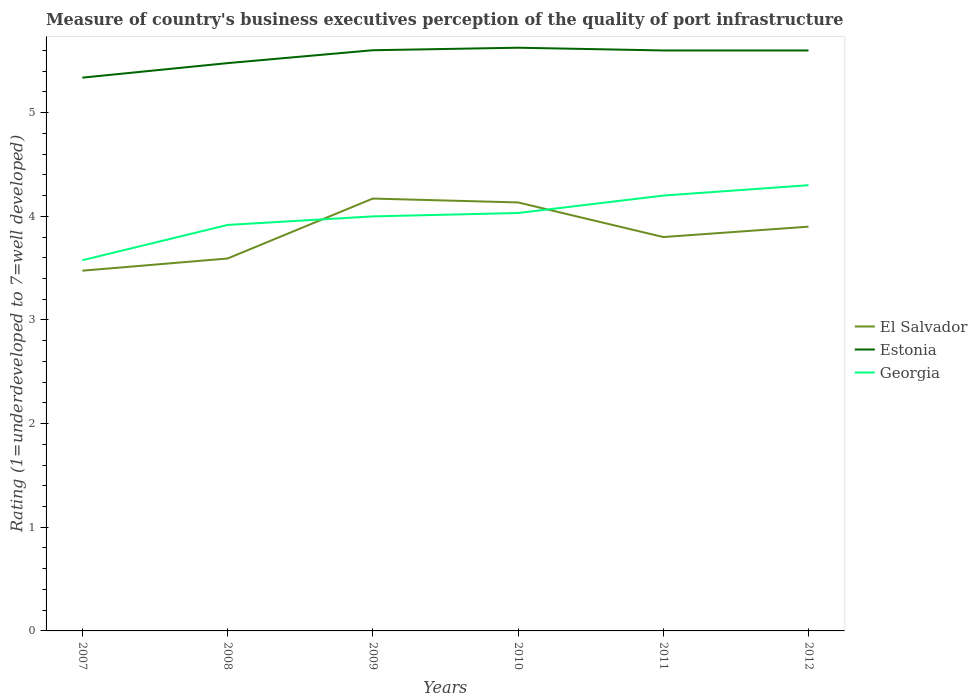Does the line corresponding to Estonia intersect with the line corresponding to Georgia?
Offer a terse response. No. Across all years, what is the maximum ratings of the quality of port infrastructure in Estonia?
Keep it short and to the point. 5.34. What is the total ratings of the quality of port infrastructure in Estonia in the graph?
Keep it short and to the point. -0.12. What is the difference between the highest and the second highest ratings of the quality of port infrastructure in Estonia?
Your answer should be compact. 0.29. What is the difference between the highest and the lowest ratings of the quality of port infrastructure in El Salvador?
Provide a short and direct response. 3. Is the ratings of the quality of port infrastructure in El Salvador strictly greater than the ratings of the quality of port infrastructure in Estonia over the years?
Keep it short and to the point. Yes. How many lines are there?
Your response must be concise. 3. What is the difference between two consecutive major ticks on the Y-axis?
Offer a very short reply. 1. Are the values on the major ticks of Y-axis written in scientific E-notation?
Offer a very short reply. No. Does the graph contain any zero values?
Give a very brief answer. No. Where does the legend appear in the graph?
Provide a short and direct response. Center right. How are the legend labels stacked?
Make the answer very short. Vertical. What is the title of the graph?
Provide a short and direct response. Measure of country's business executives perception of the quality of port infrastructure. Does "Romania" appear as one of the legend labels in the graph?
Offer a very short reply. No. What is the label or title of the Y-axis?
Your answer should be very brief. Rating (1=underdeveloped to 7=well developed). What is the Rating (1=underdeveloped to 7=well developed) of El Salvador in 2007?
Give a very brief answer. 3.48. What is the Rating (1=underdeveloped to 7=well developed) in Estonia in 2007?
Offer a very short reply. 5.34. What is the Rating (1=underdeveloped to 7=well developed) in Georgia in 2007?
Provide a succinct answer. 3.58. What is the Rating (1=underdeveloped to 7=well developed) of El Salvador in 2008?
Provide a succinct answer. 3.59. What is the Rating (1=underdeveloped to 7=well developed) of Estonia in 2008?
Give a very brief answer. 5.48. What is the Rating (1=underdeveloped to 7=well developed) of Georgia in 2008?
Offer a very short reply. 3.92. What is the Rating (1=underdeveloped to 7=well developed) in El Salvador in 2009?
Offer a very short reply. 4.17. What is the Rating (1=underdeveloped to 7=well developed) of Estonia in 2009?
Offer a terse response. 5.6. What is the Rating (1=underdeveloped to 7=well developed) of Georgia in 2009?
Make the answer very short. 4. What is the Rating (1=underdeveloped to 7=well developed) in El Salvador in 2010?
Your answer should be very brief. 4.13. What is the Rating (1=underdeveloped to 7=well developed) in Estonia in 2010?
Provide a short and direct response. 5.63. What is the Rating (1=underdeveloped to 7=well developed) in Georgia in 2010?
Your answer should be very brief. 4.03. What is the Rating (1=underdeveloped to 7=well developed) of El Salvador in 2011?
Your response must be concise. 3.8. What is the Rating (1=underdeveloped to 7=well developed) in Estonia in 2012?
Provide a short and direct response. 5.6. What is the Rating (1=underdeveloped to 7=well developed) in Georgia in 2012?
Offer a terse response. 4.3. Across all years, what is the maximum Rating (1=underdeveloped to 7=well developed) of El Salvador?
Provide a succinct answer. 4.17. Across all years, what is the maximum Rating (1=underdeveloped to 7=well developed) in Estonia?
Your response must be concise. 5.63. Across all years, what is the maximum Rating (1=underdeveloped to 7=well developed) in Georgia?
Provide a short and direct response. 4.3. Across all years, what is the minimum Rating (1=underdeveloped to 7=well developed) of El Salvador?
Give a very brief answer. 3.48. Across all years, what is the minimum Rating (1=underdeveloped to 7=well developed) in Estonia?
Provide a short and direct response. 5.34. Across all years, what is the minimum Rating (1=underdeveloped to 7=well developed) in Georgia?
Offer a terse response. 3.58. What is the total Rating (1=underdeveloped to 7=well developed) of El Salvador in the graph?
Provide a short and direct response. 23.07. What is the total Rating (1=underdeveloped to 7=well developed) in Estonia in the graph?
Offer a terse response. 33.24. What is the total Rating (1=underdeveloped to 7=well developed) of Georgia in the graph?
Provide a short and direct response. 24.02. What is the difference between the Rating (1=underdeveloped to 7=well developed) in El Salvador in 2007 and that in 2008?
Give a very brief answer. -0.12. What is the difference between the Rating (1=underdeveloped to 7=well developed) in Estonia in 2007 and that in 2008?
Your answer should be compact. -0.14. What is the difference between the Rating (1=underdeveloped to 7=well developed) of Georgia in 2007 and that in 2008?
Give a very brief answer. -0.34. What is the difference between the Rating (1=underdeveloped to 7=well developed) of El Salvador in 2007 and that in 2009?
Your response must be concise. -0.7. What is the difference between the Rating (1=underdeveloped to 7=well developed) of Estonia in 2007 and that in 2009?
Your response must be concise. -0.26. What is the difference between the Rating (1=underdeveloped to 7=well developed) of Georgia in 2007 and that in 2009?
Provide a succinct answer. -0.42. What is the difference between the Rating (1=underdeveloped to 7=well developed) in El Salvador in 2007 and that in 2010?
Make the answer very short. -0.66. What is the difference between the Rating (1=underdeveloped to 7=well developed) of Estonia in 2007 and that in 2010?
Give a very brief answer. -0.29. What is the difference between the Rating (1=underdeveloped to 7=well developed) in Georgia in 2007 and that in 2010?
Ensure brevity in your answer.  -0.46. What is the difference between the Rating (1=underdeveloped to 7=well developed) of El Salvador in 2007 and that in 2011?
Make the answer very short. -0.32. What is the difference between the Rating (1=underdeveloped to 7=well developed) in Estonia in 2007 and that in 2011?
Your answer should be very brief. -0.26. What is the difference between the Rating (1=underdeveloped to 7=well developed) in Georgia in 2007 and that in 2011?
Your response must be concise. -0.62. What is the difference between the Rating (1=underdeveloped to 7=well developed) in El Salvador in 2007 and that in 2012?
Provide a succinct answer. -0.42. What is the difference between the Rating (1=underdeveloped to 7=well developed) in Estonia in 2007 and that in 2012?
Keep it short and to the point. -0.26. What is the difference between the Rating (1=underdeveloped to 7=well developed) in Georgia in 2007 and that in 2012?
Provide a succinct answer. -0.72. What is the difference between the Rating (1=underdeveloped to 7=well developed) in El Salvador in 2008 and that in 2009?
Your answer should be very brief. -0.58. What is the difference between the Rating (1=underdeveloped to 7=well developed) of Estonia in 2008 and that in 2009?
Your answer should be compact. -0.12. What is the difference between the Rating (1=underdeveloped to 7=well developed) of Georgia in 2008 and that in 2009?
Provide a succinct answer. -0.08. What is the difference between the Rating (1=underdeveloped to 7=well developed) of El Salvador in 2008 and that in 2010?
Your answer should be very brief. -0.54. What is the difference between the Rating (1=underdeveloped to 7=well developed) in Estonia in 2008 and that in 2010?
Your response must be concise. -0.15. What is the difference between the Rating (1=underdeveloped to 7=well developed) of Georgia in 2008 and that in 2010?
Give a very brief answer. -0.12. What is the difference between the Rating (1=underdeveloped to 7=well developed) in El Salvador in 2008 and that in 2011?
Give a very brief answer. -0.21. What is the difference between the Rating (1=underdeveloped to 7=well developed) in Estonia in 2008 and that in 2011?
Your answer should be compact. -0.12. What is the difference between the Rating (1=underdeveloped to 7=well developed) in Georgia in 2008 and that in 2011?
Offer a very short reply. -0.28. What is the difference between the Rating (1=underdeveloped to 7=well developed) of El Salvador in 2008 and that in 2012?
Give a very brief answer. -0.31. What is the difference between the Rating (1=underdeveloped to 7=well developed) in Estonia in 2008 and that in 2012?
Offer a terse response. -0.12. What is the difference between the Rating (1=underdeveloped to 7=well developed) in Georgia in 2008 and that in 2012?
Provide a short and direct response. -0.38. What is the difference between the Rating (1=underdeveloped to 7=well developed) in El Salvador in 2009 and that in 2010?
Offer a very short reply. 0.04. What is the difference between the Rating (1=underdeveloped to 7=well developed) in Estonia in 2009 and that in 2010?
Offer a very short reply. -0.02. What is the difference between the Rating (1=underdeveloped to 7=well developed) in Georgia in 2009 and that in 2010?
Provide a short and direct response. -0.03. What is the difference between the Rating (1=underdeveloped to 7=well developed) in El Salvador in 2009 and that in 2011?
Your answer should be compact. 0.37. What is the difference between the Rating (1=underdeveloped to 7=well developed) of Estonia in 2009 and that in 2011?
Give a very brief answer. 0. What is the difference between the Rating (1=underdeveloped to 7=well developed) of Georgia in 2009 and that in 2011?
Make the answer very short. -0.2. What is the difference between the Rating (1=underdeveloped to 7=well developed) of El Salvador in 2009 and that in 2012?
Provide a succinct answer. 0.27. What is the difference between the Rating (1=underdeveloped to 7=well developed) of Estonia in 2009 and that in 2012?
Ensure brevity in your answer.  0. What is the difference between the Rating (1=underdeveloped to 7=well developed) of Georgia in 2009 and that in 2012?
Provide a succinct answer. -0.3. What is the difference between the Rating (1=underdeveloped to 7=well developed) in El Salvador in 2010 and that in 2011?
Offer a terse response. 0.33. What is the difference between the Rating (1=underdeveloped to 7=well developed) of Estonia in 2010 and that in 2011?
Your answer should be very brief. 0.03. What is the difference between the Rating (1=underdeveloped to 7=well developed) in Georgia in 2010 and that in 2011?
Offer a very short reply. -0.17. What is the difference between the Rating (1=underdeveloped to 7=well developed) of El Salvador in 2010 and that in 2012?
Your response must be concise. 0.23. What is the difference between the Rating (1=underdeveloped to 7=well developed) in Estonia in 2010 and that in 2012?
Your answer should be compact. 0.03. What is the difference between the Rating (1=underdeveloped to 7=well developed) of Georgia in 2010 and that in 2012?
Your response must be concise. -0.27. What is the difference between the Rating (1=underdeveloped to 7=well developed) of Estonia in 2011 and that in 2012?
Make the answer very short. 0. What is the difference between the Rating (1=underdeveloped to 7=well developed) of El Salvador in 2007 and the Rating (1=underdeveloped to 7=well developed) of Estonia in 2008?
Give a very brief answer. -2. What is the difference between the Rating (1=underdeveloped to 7=well developed) in El Salvador in 2007 and the Rating (1=underdeveloped to 7=well developed) in Georgia in 2008?
Make the answer very short. -0.44. What is the difference between the Rating (1=underdeveloped to 7=well developed) in Estonia in 2007 and the Rating (1=underdeveloped to 7=well developed) in Georgia in 2008?
Your answer should be compact. 1.42. What is the difference between the Rating (1=underdeveloped to 7=well developed) in El Salvador in 2007 and the Rating (1=underdeveloped to 7=well developed) in Estonia in 2009?
Provide a succinct answer. -2.13. What is the difference between the Rating (1=underdeveloped to 7=well developed) in El Salvador in 2007 and the Rating (1=underdeveloped to 7=well developed) in Georgia in 2009?
Offer a terse response. -0.52. What is the difference between the Rating (1=underdeveloped to 7=well developed) in Estonia in 2007 and the Rating (1=underdeveloped to 7=well developed) in Georgia in 2009?
Your answer should be very brief. 1.34. What is the difference between the Rating (1=underdeveloped to 7=well developed) in El Salvador in 2007 and the Rating (1=underdeveloped to 7=well developed) in Estonia in 2010?
Provide a short and direct response. -2.15. What is the difference between the Rating (1=underdeveloped to 7=well developed) in El Salvador in 2007 and the Rating (1=underdeveloped to 7=well developed) in Georgia in 2010?
Provide a short and direct response. -0.56. What is the difference between the Rating (1=underdeveloped to 7=well developed) in Estonia in 2007 and the Rating (1=underdeveloped to 7=well developed) in Georgia in 2010?
Keep it short and to the point. 1.31. What is the difference between the Rating (1=underdeveloped to 7=well developed) of El Salvador in 2007 and the Rating (1=underdeveloped to 7=well developed) of Estonia in 2011?
Your answer should be compact. -2.12. What is the difference between the Rating (1=underdeveloped to 7=well developed) in El Salvador in 2007 and the Rating (1=underdeveloped to 7=well developed) in Georgia in 2011?
Your answer should be very brief. -0.72. What is the difference between the Rating (1=underdeveloped to 7=well developed) in Estonia in 2007 and the Rating (1=underdeveloped to 7=well developed) in Georgia in 2011?
Offer a terse response. 1.14. What is the difference between the Rating (1=underdeveloped to 7=well developed) in El Salvador in 2007 and the Rating (1=underdeveloped to 7=well developed) in Estonia in 2012?
Your response must be concise. -2.12. What is the difference between the Rating (1=underdeveloped to 7=well developed) in El Salvador in 2007 and the Rating (1=underdeveloped to 7=well developed) in Georgia in 2012?
Give a very brief answer. -0.82. What is the difference between the Rating (1=underdeveloped to 7=well developed) in Estonia in 2007 and the Rating (1=underdeveloped to 7=well developed) in Georgia in 2012?
Give a very brief answer. 1.04. What is the difference between the Rating (1=underdeveloped to 7=well developed) of El Salvador in 2008 and the Rating (1=underdeveloped to 7=well developed) of Estonia in 2009?
Give a very brief answer. -2.01. What is the difference between the Rating (1=underdeveloped to 7=well developed) in El Salvador in 2008 and the Rating (1=underdeveloped to 7=well developed) in Georgia in 2009?
Offer a very short reply. -0.41. What is the difference between the Rating (1=underdeveloped to 7=well developed) of Estonia in 2008 and the Rating (1=underdeveloped to 7=well developed) of Georgia in 2009?
Keep it short and to the point. 1.48. What is the difference between the Rating (1=underdeveloped to 7=well developed) of El Salvador in 2008 and the Rating (1=underdeveloped to 7=well developed) of Estonia in 2010?
Offer a very short reply. -2.03. What is the difference between the Rating (1=underdeveloped to 7=well developed) of El Salvador in 2008 and the Rating (1=underdeveloped to 7=well developed) of Georgia in 2010?
Ensure brevity in your answer.  -0.44. What is the difference between the Rating (1=underdeveloped to 7=well developed) of Estonia in 2008 and the Rating (1=underdeveloped to 7=well developed) of Georgia in 2010?
Provide a short and direct response. 1.45. What is the difference between the Rating (1=underdeveloped to 7=well developed) in El Salvador in 2008 and the Rating (1=underdeveloped to 7=well developed) in Estonia in 2011?
Your answer should be compact. -2.01. What is the difference between the Rating (1=underdeveloped to 7=well developed) in El Salvador in 2008 and the Rating (1=underdeveloped to 7=well developed) in Georgia in 2011?
Provide a succinct answer. -0.61. What is the difference between the Rating (1=underdeveloped to 7=well developed) in Estonia in 2008 and the Rating (1=underdeveloped to 7=well developed) in Georgia in 2011?
Offer a terse response. 1.28. What is the difference between the Rating (1=underdeveloped to 7=well developed) in El Salvador in 2008 and the Rating (1=underdeveloped to 7=well developed) in Estonia in 2012?
Your answer should be compact. -2.01. What is the difference between the Rating (1=underdeveloped to 7=well developed) of El Salvador in 2008 and the Rating (1=underdeveloped to 7=well developed) of Georgia in 2012?
Provide a succinct answer. -0.71. What is the difference between the Rating (1=underdeveloped to 7=well developed) in Estonia in 2008 and the Rating (1=underdeveloped to 7=well developed) in Georgia in 2012?
Make the answer very short. 1.18. What is the difference between the Rating (1=underdeveloped to 7=well developed) of El Salvador in 2009 and the Rating (1=underdeveloped to 7=well developed) of Estonia in 2010?
Ensure brevity in your answer.  -1.46. What is the difference between the Rating (1=underdeveloped to 7=well developed) of El Salvador in 2009 and the Rating (1=underdeveloped to 7=well developed) of Georgia in 2010?
Your answer should be compact. 0.14. What is the difference between the Rating (1=underdeveloped to 7=well developed) in Estonia in 2009 and the Rating (1=underdeveloped to 7=well developed) in Georgia in 2010?
Offer a terse response. 1.57. What is the difference between the Rating (1=underdeveloped to 7=well developed) of El Salvador in 2009 and the Rating (1=underdeveloped to 7=well developed) of Estonia in 2011?
Your answer should be very brief. -1.43. What is the difference between the Rating (1=underdeveloped to 7=well developed) of El Salvador in 2009 and the Rating (1=underdeveloped to 7=well developed) of Georgia in 2011?
Make the answer very short. -0.03. What is the difference between the Rating (1=underdeveloped to 7=well developed) in Estonia in 2009 and the Rating (1=underdeveloped to 7=well developed) in Georgia in 2011?
Ensure brevity in your answer.  1.4. What is the difference between the Rating (1=underdeveloped to 7=well developed) of El Salvador in 2009 and the Rating (1=underdeveloped to 7=well developed) of Estonia in 2012?
Provide a succinct answer. -1.43. What is the difference between the Rating (1=underdeveloped to 7=well developed) in El Salvador in 2009 and the Rating (1=underdeveloped to 7=well developed) in Georgia in 2012?
Keep it short and to the point. -0.13. What is the difference between the Rating (1=underdeveloped to 7=well developed) in Estonia in 2009 and the Rating (1=underdeveloped to 7=well developed) in Georgia in 2012?
Offer a very short reply. 1.3. What is the difference between the Rating (1=underdeveloped to 7=well developed) of El Salvador in 2010 and the Rating (1=underdeveloped to 7=well developed) of Estonia in 2011?
Keep it short and to the point. -1.47. What is the difference between the Rating (1=underdeveloped to 7=well developed) in El Salvador in 2010 and the Rating (1=underdeveloped to 7=well developed) in Georgia in 2011?
Ensure brevity in your answer.  -0.07. What is the difference between the Rating (1=underdeveloped to 7=well developed) of Estonia in 2010 and the Rating (1=underdeveloped to 7=well developed) of Georgia in 2011?
Give a very brief answer. 1.43. What is the difference between the Rating (1=underdeveloped to 7=well developed) in El Salvador in 2010 and the Rating (1=underdeveloped to 7=well developed) in Estonia in 2012?
Offer a terse response. -1.47. What is the difference between the Rating (1=underdeveloped to 7=well developed) of El Salvador in 2010 and the Rating (1=underdeveloped to 7=well developed) of Georgia in 2012?
Give a very brief answer. -0.17. What is the difference between the Rating (1=underdeveloped to 7=well developed) in Estonia in 2010 and the Rating (1=underdeveloped to 7=well developed) in Georgia in 2012?
Keep it short and to the point. 1.33. What is the difference between the Rating (1=underdeveloped to 7=well developed) of El Salvador in 2011 and the Rating (1=underdeveloped to 7=well developed) of Georgia in 2012?
Your response must be concise. -0.5. What is the average Rating (1=underdeveloped to 7=well developed) of El Salvador per year?
Offer a very short reply. 3.85. What is the average Rating (1=underdeveloped to 7=well developed) in Estonia per year?
Your response must be concise. 5.54. What is the average Rating (1=underdeveloped to 7=well developed) of Georgia per year?
Give a very brief answer. 4. In the year 2007, what is the difference between the Rating (1=underdeveloped to 7=well developed) of El Salvador and Rating (1=underdeveloped to 7=well developed) of Estonia?
Offer a terse response. -1.86. In the year 2007, what is the difference between the Rating (1=underdeveloped to 7=well developed) in El Salvador and Rating (1=underdeveloped to 7=well developed) in Georgia?
Offer a very short reply. -0.1. In the year 2007, what is the difference between the Rating (1=underdeveloped to 7=well developed) in Estonia and Rating (1=underdeveloped to 7=well developed) in Georgia?
Keep it short and to the point. 1.76. In the year 2008, what is the difference between the Rating (1=underdeveloped to 7=well developed) of El Salvador and Rating (1=underdeveloped to 7=well developed) of Estonia?
Ensure brevity in your answer.  -1.88. In the year 2008, what is the difference between the Rating (1=underdeveloped to 7=well developed) of El Salvador and Rating (1=underdeveloped to 7=well developed) of Georgia?
Keep it short and to the point. -0.32. In the year 2008, what is the difference between the Rating (1=underdeveloped to 7=well developed) of Estonia and Rating (1=underdeveloped to 7=well developed) of Georgia?
Keep it short and to the point. 1.56. In the year 2009, what is the difference between the Rating (1=underdeveloped to 7=well developed) in El Salvador and Rating (1=underdeveloped to 7=well developed) in Estonia?
Your answer should be compact. -1.43. In the year 2009, what is the difference between the Rating (1=underdeveloped to 7=well developed) of El Salvador and Rating (1=underdeveloped to 7=well developed) of Georgia?
Make the answer very short. 0.17. In the year 2009, what is the difference between the Rating (1=underdeveloped to 7=well developed) in Estonia and Rating (1=underdeveloped to 7=well developed) in Georgia?
Keep it short and to the point. 1.6. In the year 2010, what is the difference between the Rating (1=underdeveloped to 7=well developed) in El Salvador and Rating (1=underdeveloped to 7=well developed) in Estonia?
Your answer should be very brief. -1.49. In the year 2010, what is the difference between the Rating (1=underdeveloped to 7=well developed) of El Salvador and Rating (1=underdeveloped to 7=well developed) of Georgia?
Your answer should be compact. 0.1. In the year 2010, what is the difference between the Rating (1=underdeveloped to 7=well developed) of Estonia and Rating (1=underdeveloped to 7=well developed) of Georgia?
Your answer should be compact. 1.59. In the year 2011, what is the difference between the Rating (1=underdeveloped to 7=well developed) of El Salvador and Rating (1=underdeveloped to 7=well developed) of Georgia?
Your answer should be very brief. -0.4. In the year 2012, what is the difference between the Rating (1=underdeveloped to 7=well developed) of El Salvador and Rating (1=underdeveloped to 7=well developed) of Estonia?
Provide a short and direct response. -1.7. In the year 2012, what is the difference between the Rating (1=underdeveloped to 7=well developed) in El Salvador and Rating (1=underdeveloped to 7=well developed) in Georgia?
Offer a very short reply. -0.4. What is the ratio of the Rating (1=underdeveloped to 7=well developed) of El Salvador in 2007 to that in 2008?
Provide a succinct answer. 0.97. What is the ratio of the Rating (1=underdeveloped to 7=well developed) of Estonia in 2007 to that in 2008?
Offer a very short reply. 0.97. What is the ratio of the Rating (1=underdeveloped to 7=well developed) of Georgia in 2007 to that in 2008?
Your answer should be compact. 0.91. What is the ratio of the Rating (1=underdeveloped to 7=well developed) of El Salvador in 2007 to that in 2009?
Ensure brevity in your answer.  0.83. What is the ratio of the Rating (1=underdeveloped to 7=well developed) in Estonia in 2007 to that in 2009?
Ensure brevity in your answer.  0.95. What is the ratio of the Rating (1=underdeveloped to 7=well developed) in Georgia in 2007 to that in 2009?
Your answer should be compact. 0.89. What is the ratio of the Rating (1=underdeveloped to 7=well developed) of El Salvador in 2007 to that in 2010?
Your answer should be compact. 0.84. What is the ratio of the Rating (1=underdeveloped to 7=well developed) of Estonia in 2007 to that in 2010?
Your response must be concise. 0.95. What is the ratio of the Rating (1=underdeveloped to 7=well developed) of Georgia in 2007 to that in 2010?
Your answer should be very brief. 0.89. What is the ratio of the Rating (1=underdeveloped to 7=well developed) in El Salvador in 2007 to that in 2011?
Your response must be concise. 0.91. What is the ratio of the Rating (1=underdeveloped to 7=well developed) in Estonia in 2007 to that in 2011?
Provide a short and direct response. 0.95. What is the ratio of the Rating (1=underdeveloped to 7=well developed) of Georgia in 2007 to that in 2011?
Keep it short and to the point. 0.85. What is the ratio of the Rating (1=underdeveloped to 7=well developed) of El Salvador in 2007 to that in 2012?
Offer a very short reply. 0.89. What is the ratio of the Rating (1=underdeveloped to 7=well developed) in Estonia in 2007 to that in 2012?
Make the answer very short. 0.95. What is the ratio of the Rating (1=underdeveloped to 7=well developed) in Georgia in 2007 to that in 2012?
Provide a succinct answer. 0.83. What is the ratio of the Rating (1=underdeveloped to 7=well developed) in El Salvador in 2008 to that in 2009?
Your answer should be compact. 0.86. What is the ratio of the Rating (1=underdeveloped to 7=well developed) in Estonia in 2008 to that in 2009?
Your answer should be very brief. 0.98. What is the ratio of the Rating (1=underdeveloped to 7=well developed) in Georgia in 2008 to that in 2009?
Keep it short and to the point. 0.98. What is the ratio of the Rating (1=underdeveloped to 7=well developed) in El Salvador in 2008 to that in 2010?
Provide a succinct answer. 0.87. What is the ratio of the Rating (1=underdeveloped to 7=well developed) in Estonia in 2008 to that in 2010?
Your answer should be compact. 0.97. What is the ratio of the Rating (1=underdeveloped to 7=well developed) of Georgia in 2008 to that in 2010?
Ensure brevity in your answer.  0.97. What is the ratio of the Rating (1=underdeveloped to 7=well developed) in El Salvador in 2008 to that in 2011?
Give a very brief answer. 0.95. What is the ratio of the Rating (1=underdeveloped to 7=well developed) in Estonia in 2008 to that in 2011?
Your answer should be very brief. 0.98. What is the ratio of the Rating (1=underdeveloped to 7=well developed) of Georgia in 2008 to that in 2011?
Make the answer very short. 0.93. What is the ratio of the Rating (1=underdeveloped to 7=well developed) of El Salvador in 2008 to that in 2012?
Your answer should be compact. 0.92. What is the ratio of the Rating (1=underdeveloped to 7=well developed) of Estonia in 2008 to that in 2012?
Your response must be concise. 0.98. What is the ratio of the Rating (1=underdeveloped to 7=well developed) of Georgia in 2008 to that in 2012?
Ensure brevity in your answer.  0.91. What is the ratio of the Rating (1=underdeveloped to 7=well developed) in Estonia in 2009 to that in 2010?
Make the answer very short. 1. What is the ratio of the Rating (1=underdeveloped to 7=well developed) in El Salvador in 2009 to that in 2011?
Keep it short and to the point. 1.1. What is the ratio of the Rating (1=underdeveloped to 7=well developed) in Estonia in 2009 to that in 2011?
Offer a very short reply. 1. What is the ratio of the Rating (1=underdeveloped to 7=well developed) of Georgia in 2009 to that in 2011?
Your answer should be compact. 0.95. What is the ratio of the Rating (1=underdeveloped to 7=well developed) of El Salvador in 2009 to that in 2012?
Your answer should be very brief. 1.07. What is the ratio of the Rating (1=underdeveloped to 7=well developed) in Estonia in 2009 to that in 2012?
Your response must be concise. 1. What is the ratio of the Rating (1=underdeveloped to 7=well developed) in Georgia in 2009 to that in 2012?
Offer a terse response. 0.93. What is the ratio of the Rating (1=underdeveloped to 7=well developed) in El Salvador in 2010 to that in 2011?
Keep it short and to the point. 1.09. What is the ratio of the Rating (1=underdeveloped to 7=well developed) in Estonia in 2010 to that in 2011?
Give a very brief answer. 1. What is the ratio of the Rating (1=underdeveloped to 7=well developed) of Georgia in 2010 to that in 2011?
Ensure brevity in your answer.  0.96. What is the ratio of the Rating (1=underdeveloped to 7=well developed) of El Salvador in 2010 to that in 2012?
Ensure brevity in your answer.  1.06. What is the ratio of the Rating (1=underdeveloped to 7=well developed) of Georgia in 2010 to that in 2012?
Your answer should be very brief. 0.94. What is the ratio of the Rating (1=underdeveloped to 7=well developed) in El Salvador in 2011 to that in 2012?
Offer a terse response. 0.97. What is the ratio of the Rating (1=underdeveloped to 7=well developed) in Estonia in 2011 to that in 2012?
Make the answer very short. 1. What is the ratio of the Rating (1=underdeveloped to 7=well developed) in Georgia in 2011 to that in 2012?
Make the answer very short. 0.98. What is the difference between the highest and the second highest Rating (1=underdeveloped to 7=well developed) of El Salvador?
Your answer should be compact. 0.04. What is the difference between the highest and the second highest Rating (1=underdeveloped to 7=well developed) of Estonia?
Your answer should be very brief. 0.02. What is the difference between the highest and the lowest Rating (1=underdeveloped to 7=well developed) of El Salvador?
Provide a succinct answer. 0.7. What is the difference between the highest and the lowest Rating (1=underdeveloped to 7=well developed) in Estonia?
Provide a short and direct response. 0.29. What is the difference between the highest and the lowest Rating (1=underdeveloped to 7=well developed) of Georgia?
Ensure brevity in your answer.  0.72. 